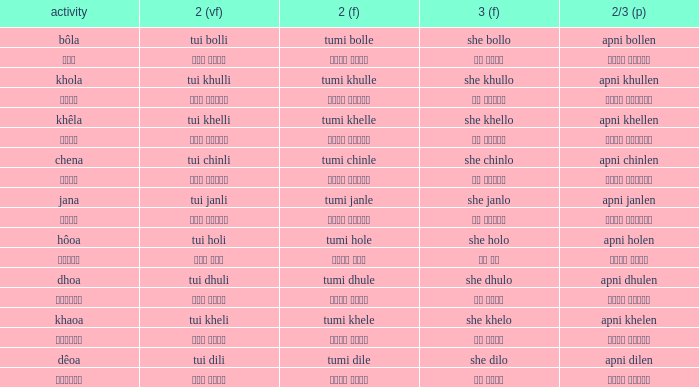What is the 3rd for the 2nd Tui Dhuli? She dhulo. 